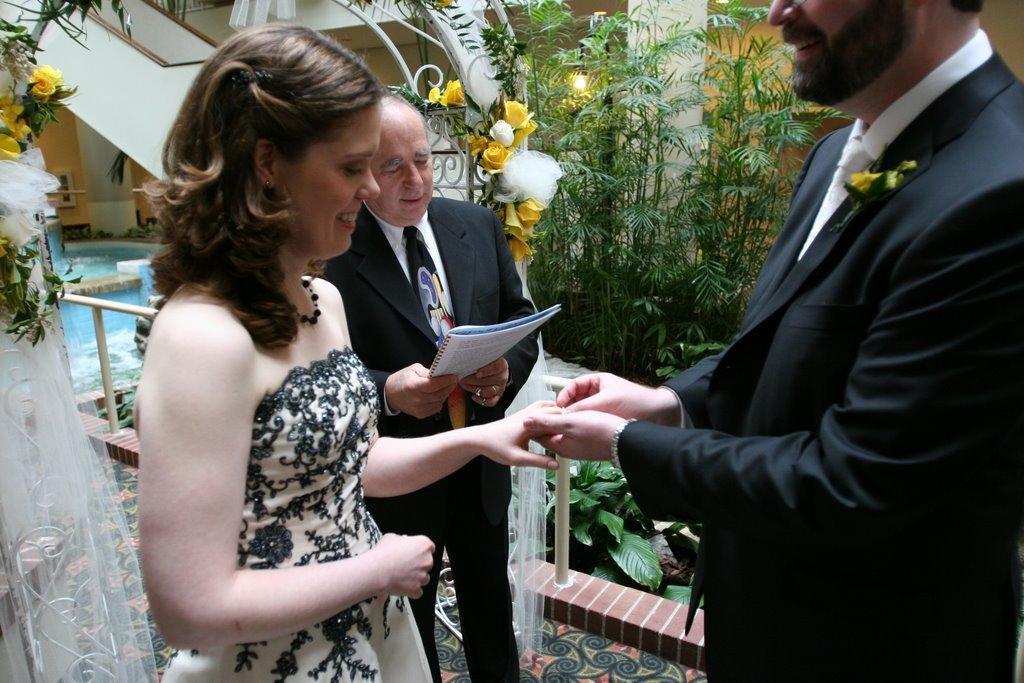Can you describe this image briefly? In this image we can see three persons, one of them is holding a book, there are plants, flowers, poles, we can see the house, water, and a light. 